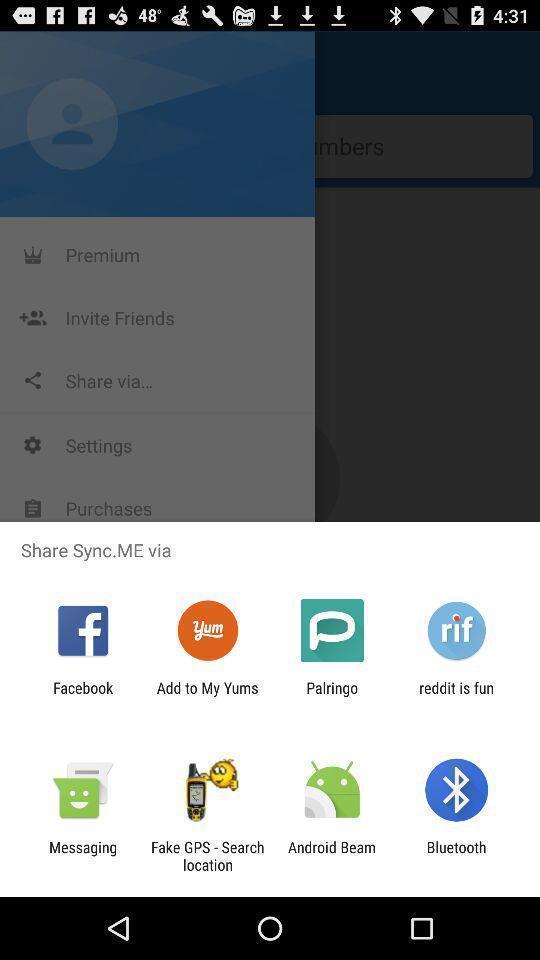Explain what's happening in this screen capture. Screen displaying to share using different social applications. 